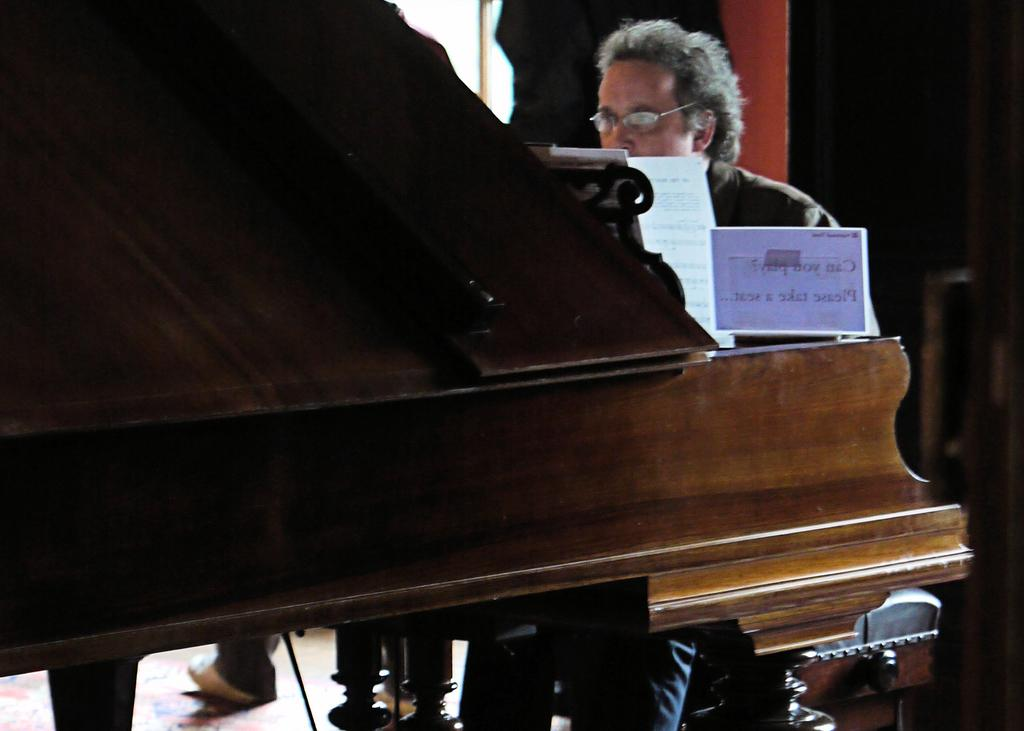Who is present in the image? There is a man in the image. What is the man doing in the image? The man is sitting next to a piano set. What accessory is the man wearing in the image? The man is wearing glasses (specs) in the image. What type of fold can be seen in the man's clothing in the image? There is no fold visible in the man's clothing in the image. How many daughters does the man have in the image? There is no information about the man's daughters in the image. Is there a rabbit present in the image? There is no rabbit present in the image. 